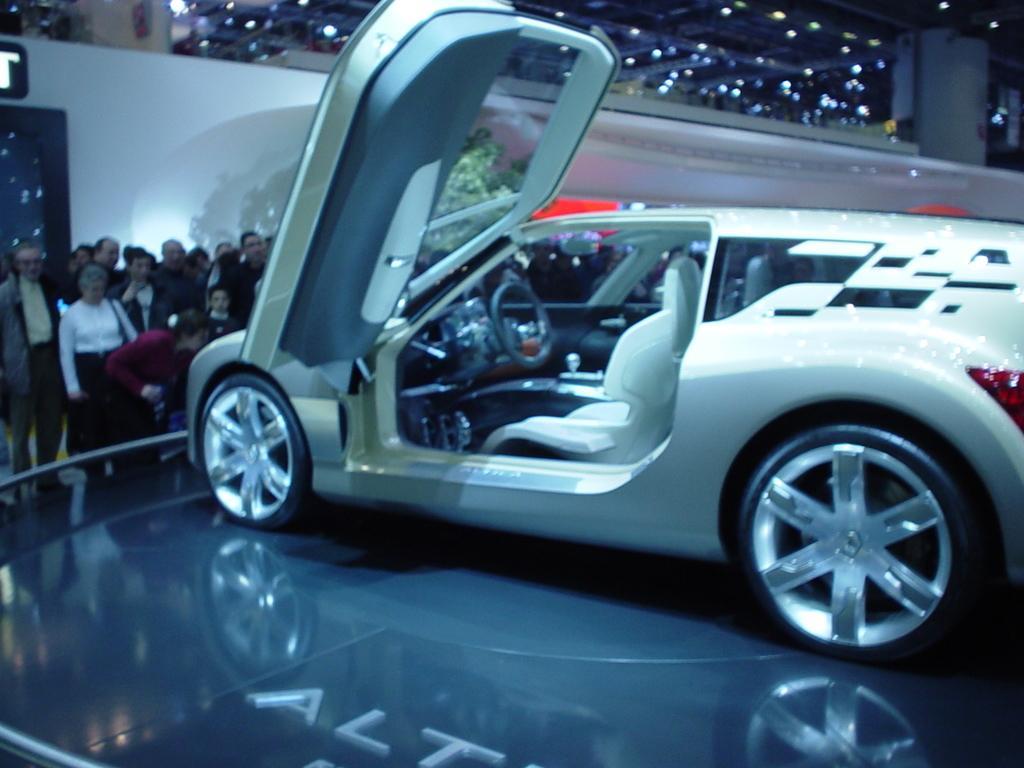Please provide a concise description of this image. In this image I can see a car which is white and black in color on the surface. In the background I can see few other persons standing, few lights and the building and I can see a tree which is green in color. 